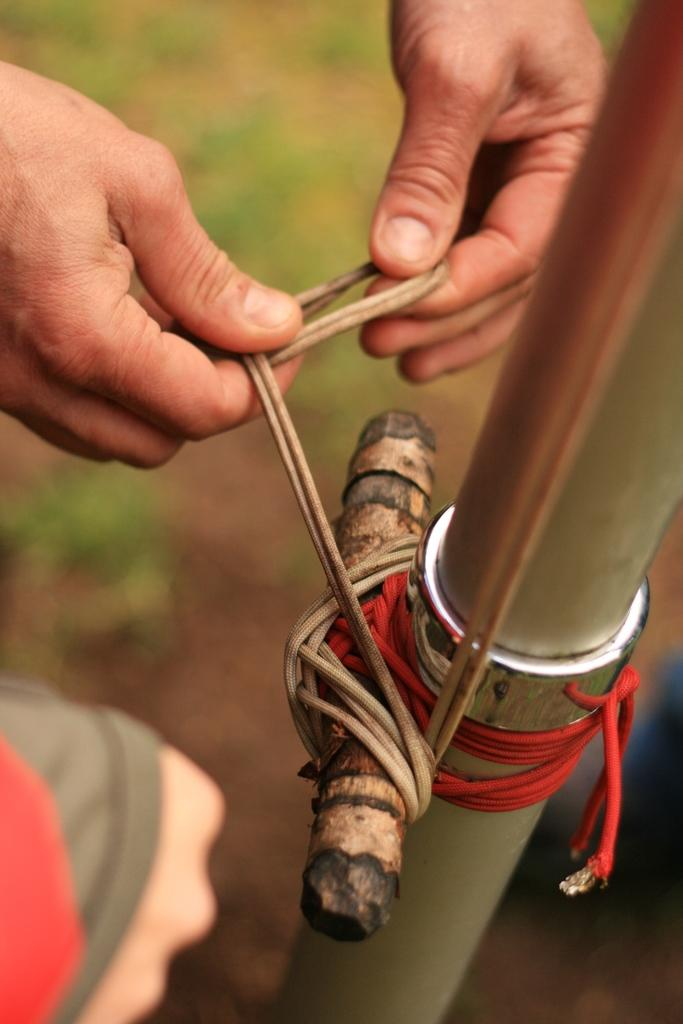What is happening in the image? There is a person in the image who is tying something to a pole with a wire. Can you describe the actions of the person in the image? The person is using a wire to secure something to a pole. Whose hand is visible in the image? The hand of another person is visible in the image. What type of engine can be seen in the image? There is no engine present in the image. How many pigs are visible in the image? There are no pigs present in the image. 